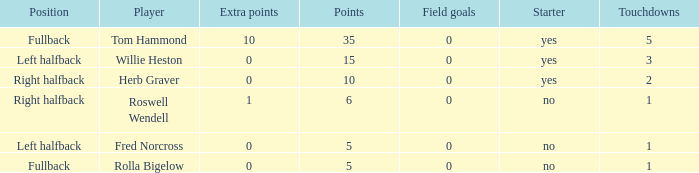What is the lowest number of field goals for a player with 3 touchdowns? 0.0. 